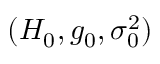<formula> <loc_0><loc_0><loc_500><loc_500>( H _ { 0 } , g _ { 0 } , \sigma _ { 0 } ^ { 2 } )</formula> 